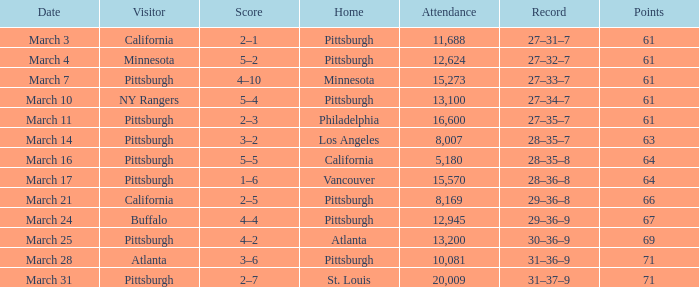What is the schedule of the match in vancouver? March 17. 